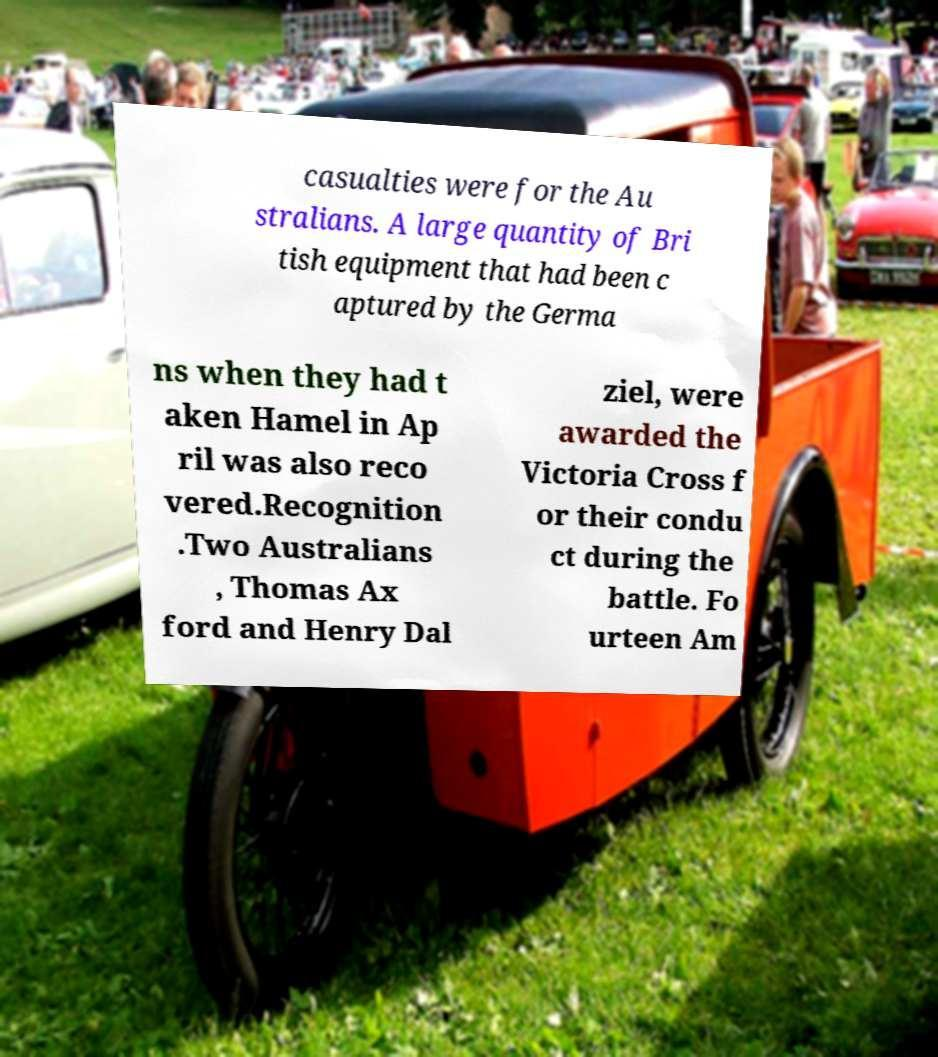I need the written content from this picture converted into text. Can you do that? casualties were for the Au stralians. A large quantity of Bri tish equipment that had been c aptured by the Germa ns when they had t aken Hamel in Ap ril was also reco vered.Recognition .Two Australians , Thomas Ax ford and Henry Dal ziel, were awarded the Victoria Cross f or their condu ct during the battle. Fo urteen Am 